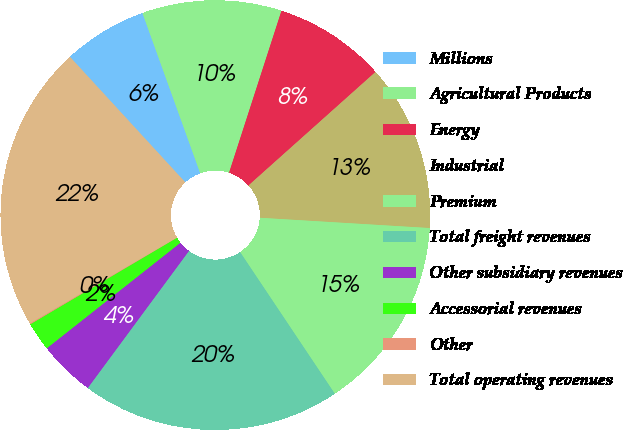Convert chart to OTSL. <chart><loc_0><loc_0><loc_500><loc_500><pie_chart><fcel>Millions<fcel>Agricultural Products<fcel>Energy<fcel>Industrial<fcel>Premium<fcel>Total freight revenues<fcel>Other subsidiary revenues<fcel>Accessorial revenues<fcel>Other<fcel>Total operating revenues<nl><fcel>6.32%<fcel>10.49%<fcel>8.41%<fcel>12.57%<fcel>14.66%<fcel>19.5%<fcel>4.24%<fcel>2.16%<fcel>0.07%<fcel>21.58%<nl></chart> 